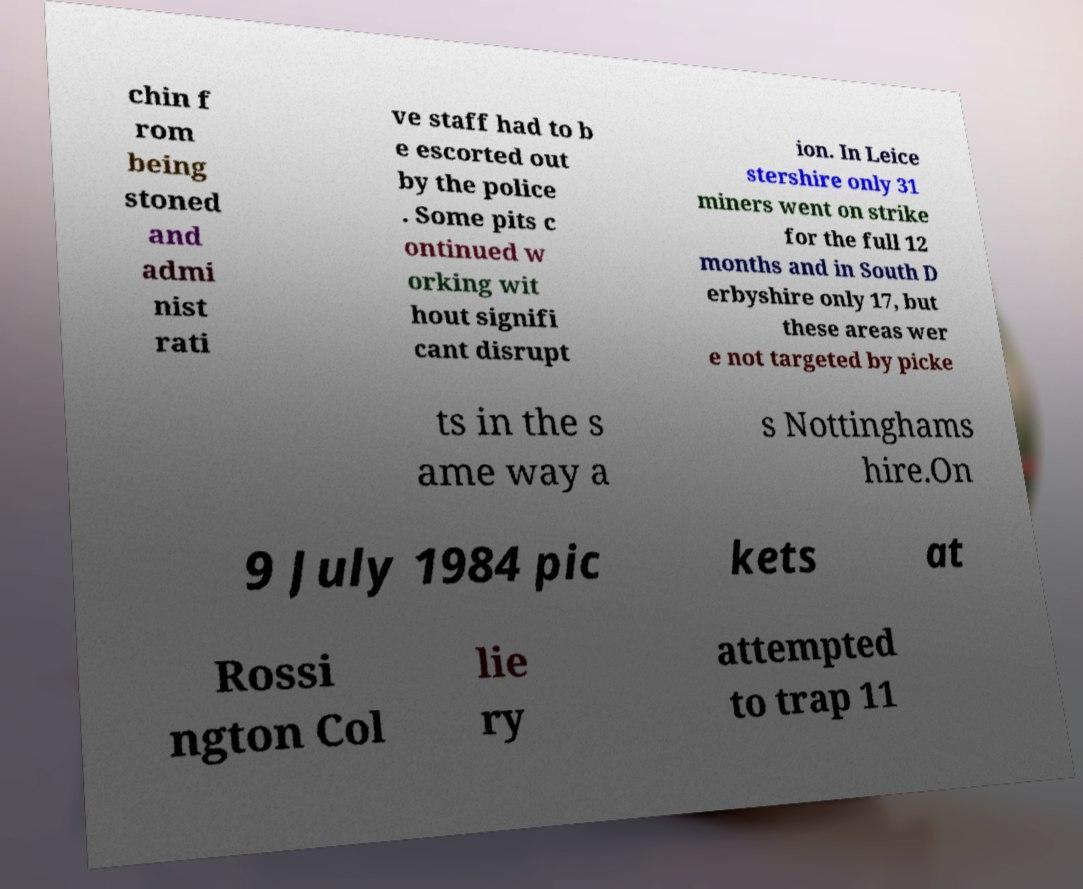Please read and relay the text visible in this image. What does it say? chin f rom being stoned and admi nist rati ve staff had to b e escorted out by the police . Some pits c ontinued w orking wit hout signifi cant disrupt ion. In Leice stershire only 31 miners went on strike for the full 12 months and in South D erbyshire only 17, but these areas wer e not targeted by picke ts in the s ame way a s Nottinghams hire.On 9 July 1984 pic kets at Rossi ngton Col lie ry attempted to trap 11 